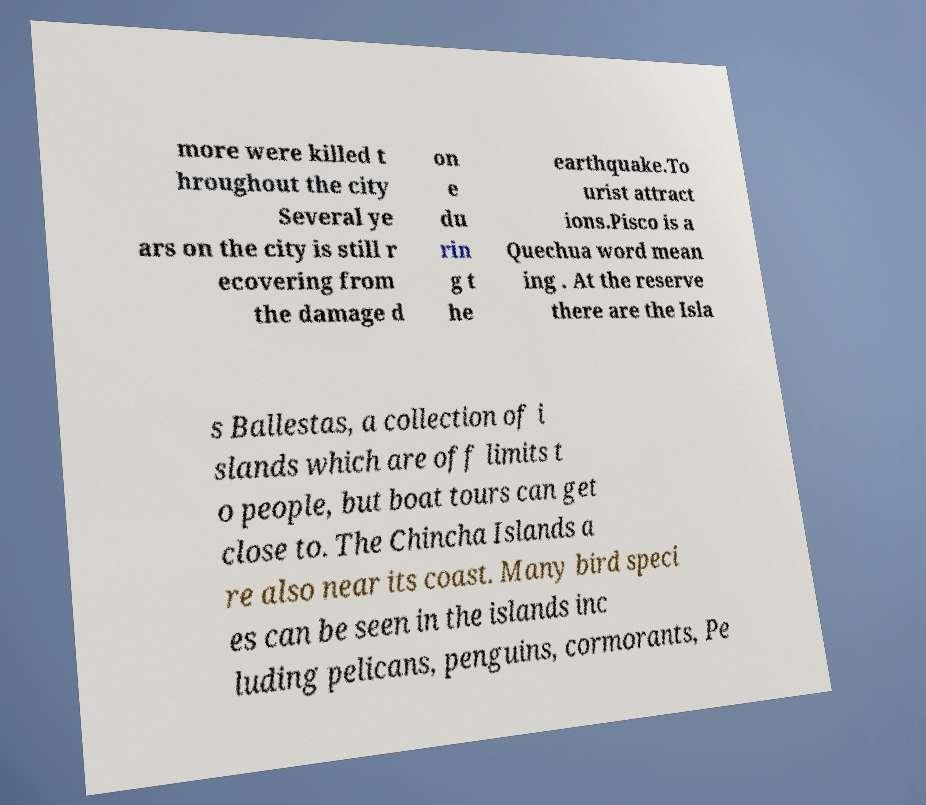For documentation purposes, I need the text within this image transcribed. Could you provide that? more were killed t hroughout the city Several ye ars on the city is still r ecovering from the damage d on e du rin g t he earthquake.To urist attract ions.Pisco is a Quechua word mean ing . At the reserve there are the Isla s Ballestas, a collection of i slands which are off limits t o people, but boat tours can get close to. The Chincha Islands a re also near its coast. Many bird speci es can be seen in the islands inc luding pelicans, penguins, cormorants, Pe 